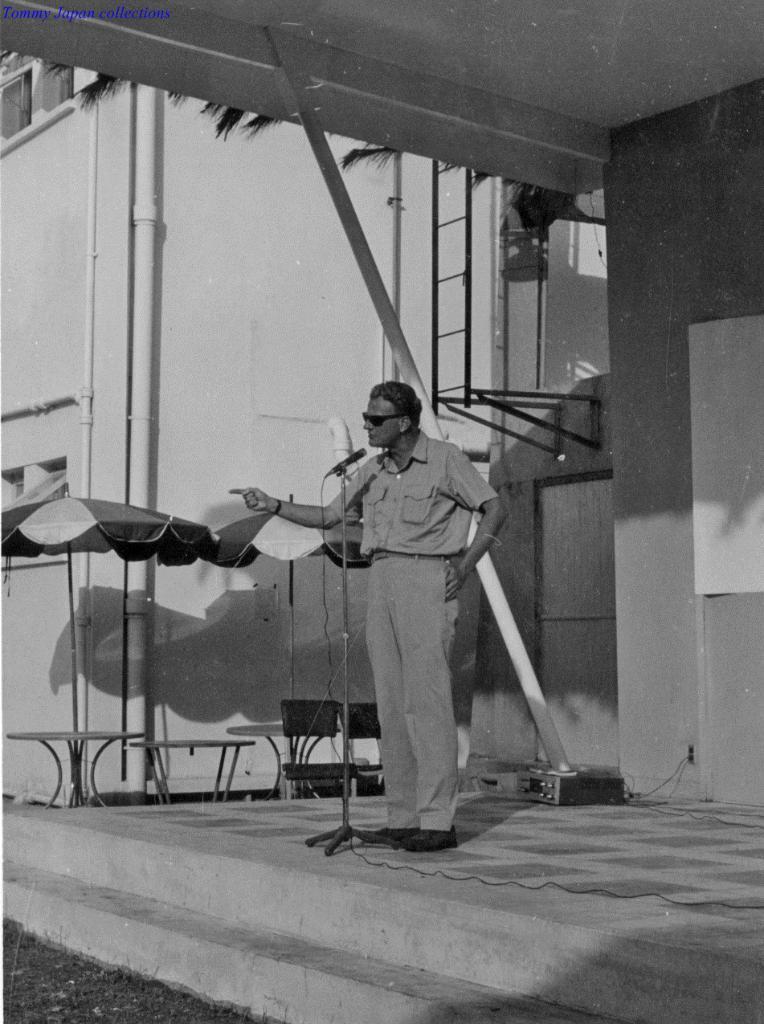In one or two sentences, can you explain what this image depicts? This is a black and white image. In this image, in the middle, we can see a man standing in front of a microphone. In the background, we can see two umbrellas, under the umbrella, we can see tables, chairs. In the background, we can also see a building, window, ladder, tree and a door. 